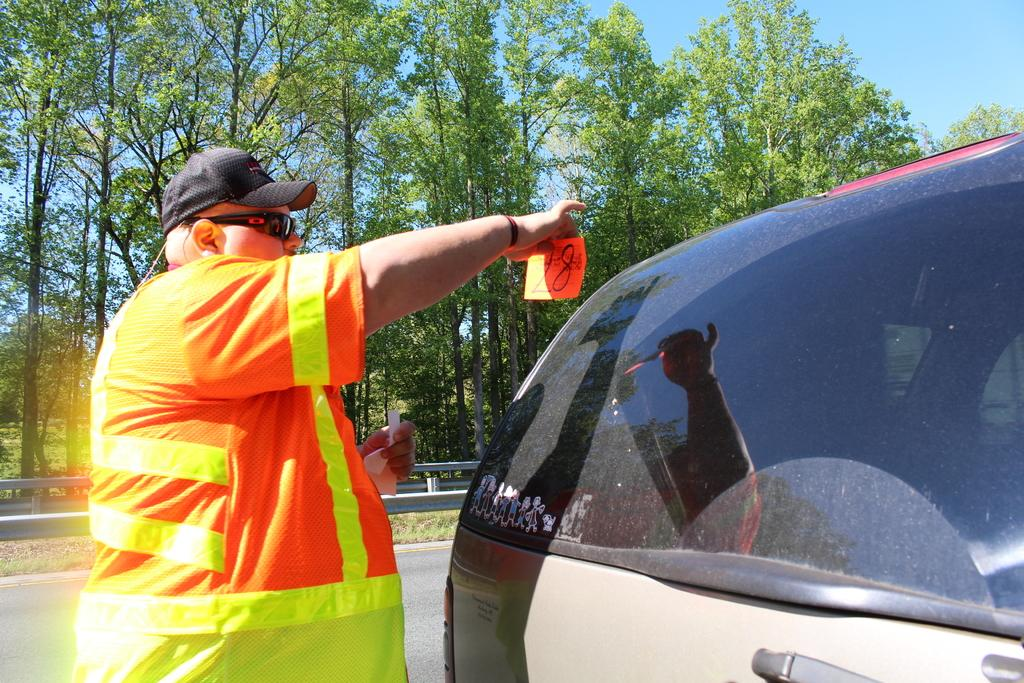What is the man in the image wearing on his head? The man is wearing a cap. What type of eyewear is the man wearing in the image? The man is wearing shades. What color are the clothes the man is wearing? The man is wearing orange color clothes. What else can be seen in the image besides the man? There is a vehicle and trees in the background of the image. What is visible in the background of the image? The sky is visible in the background of the image. Is it raining in the image? There is no indication of rain in the image. What type of holiday is the man celebrating in the image? There is no indication of a holiday being celebrated in the image. 